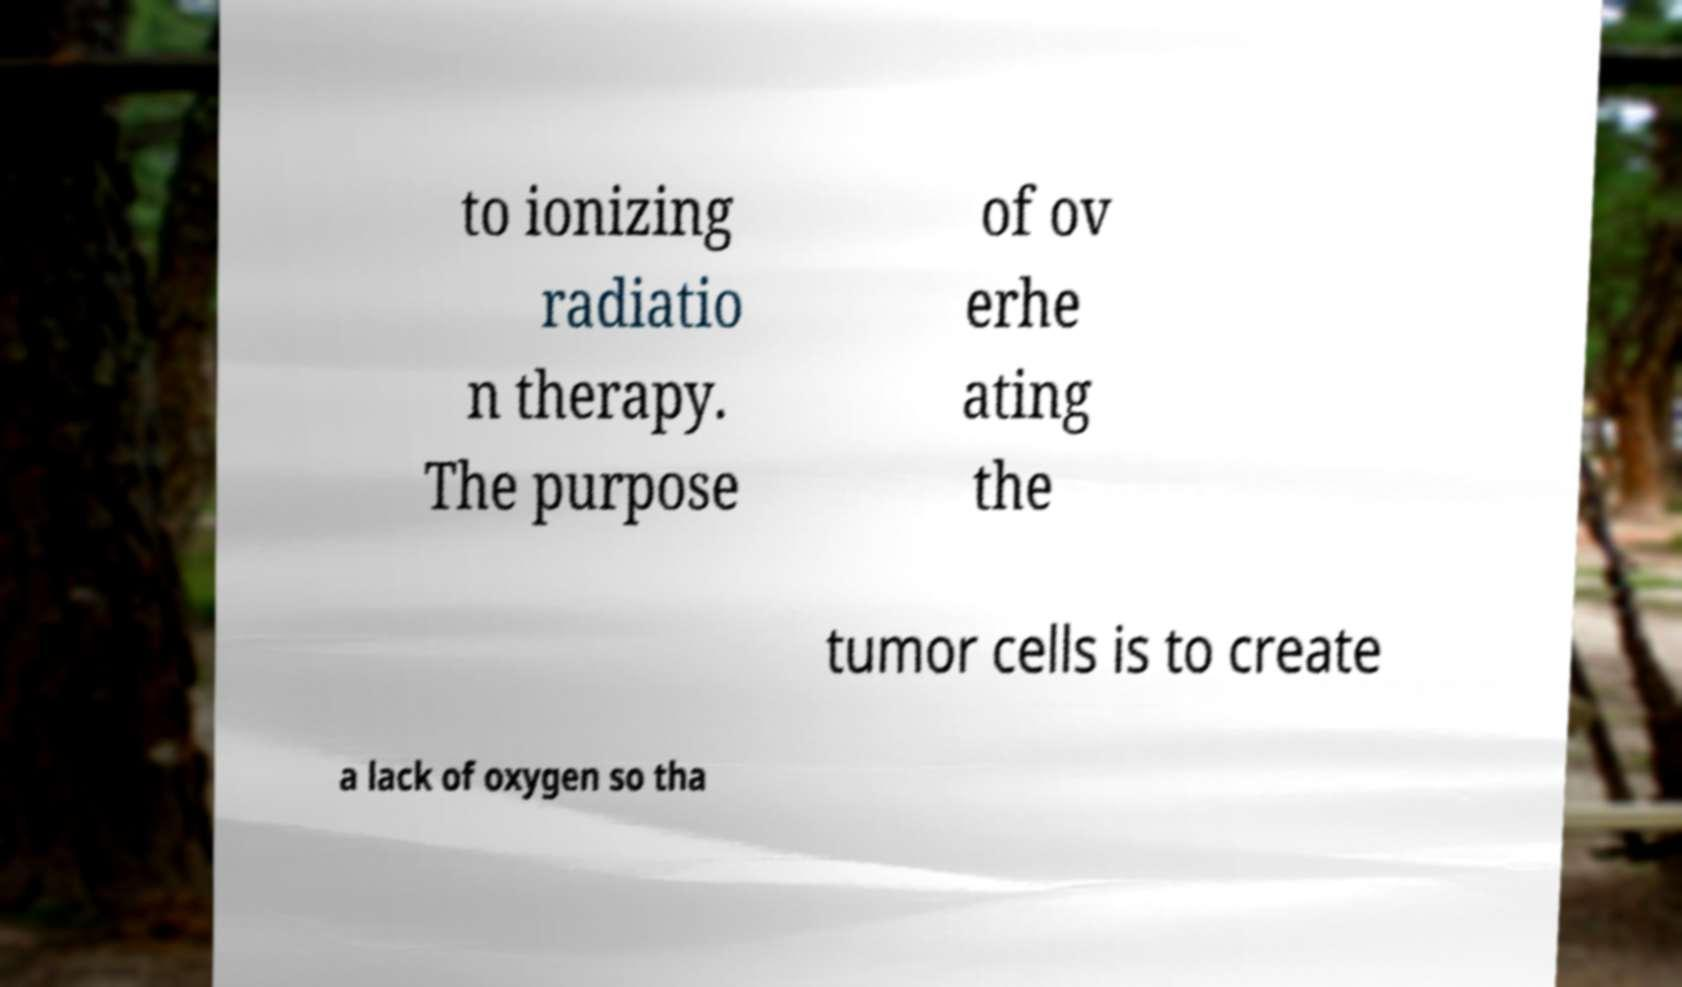What messages or text are displayed in this image? I need them in a readable, typed format. to ionizing radiatio n therapy. The purpose of ov erhe ating the tumor cells is to create a lack of oxygen so tha 